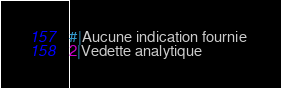Convert code to text. <code><loc_0><loc_0><loc_500><loc_500><_SQL_>#|Aucune indication fournie 
2|Vedette analytique 
</code> 